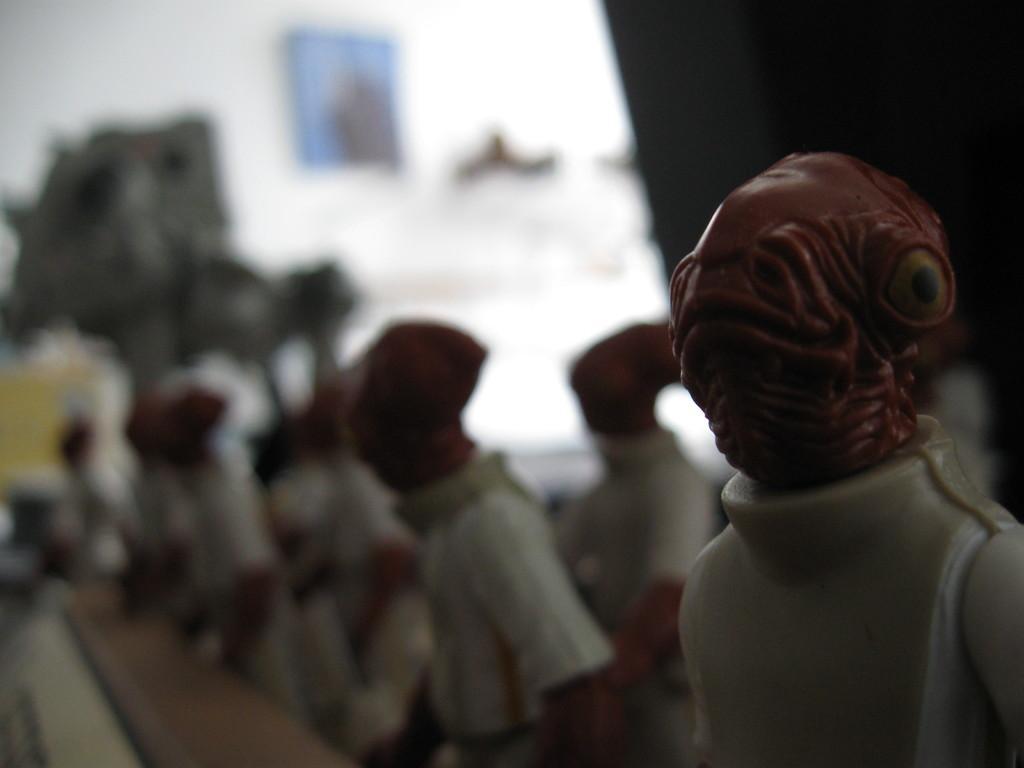Could you give a brief overview of what you see in this image? In this picture there are toys in the image and there is a portrait on the wall at the top side of the image. 